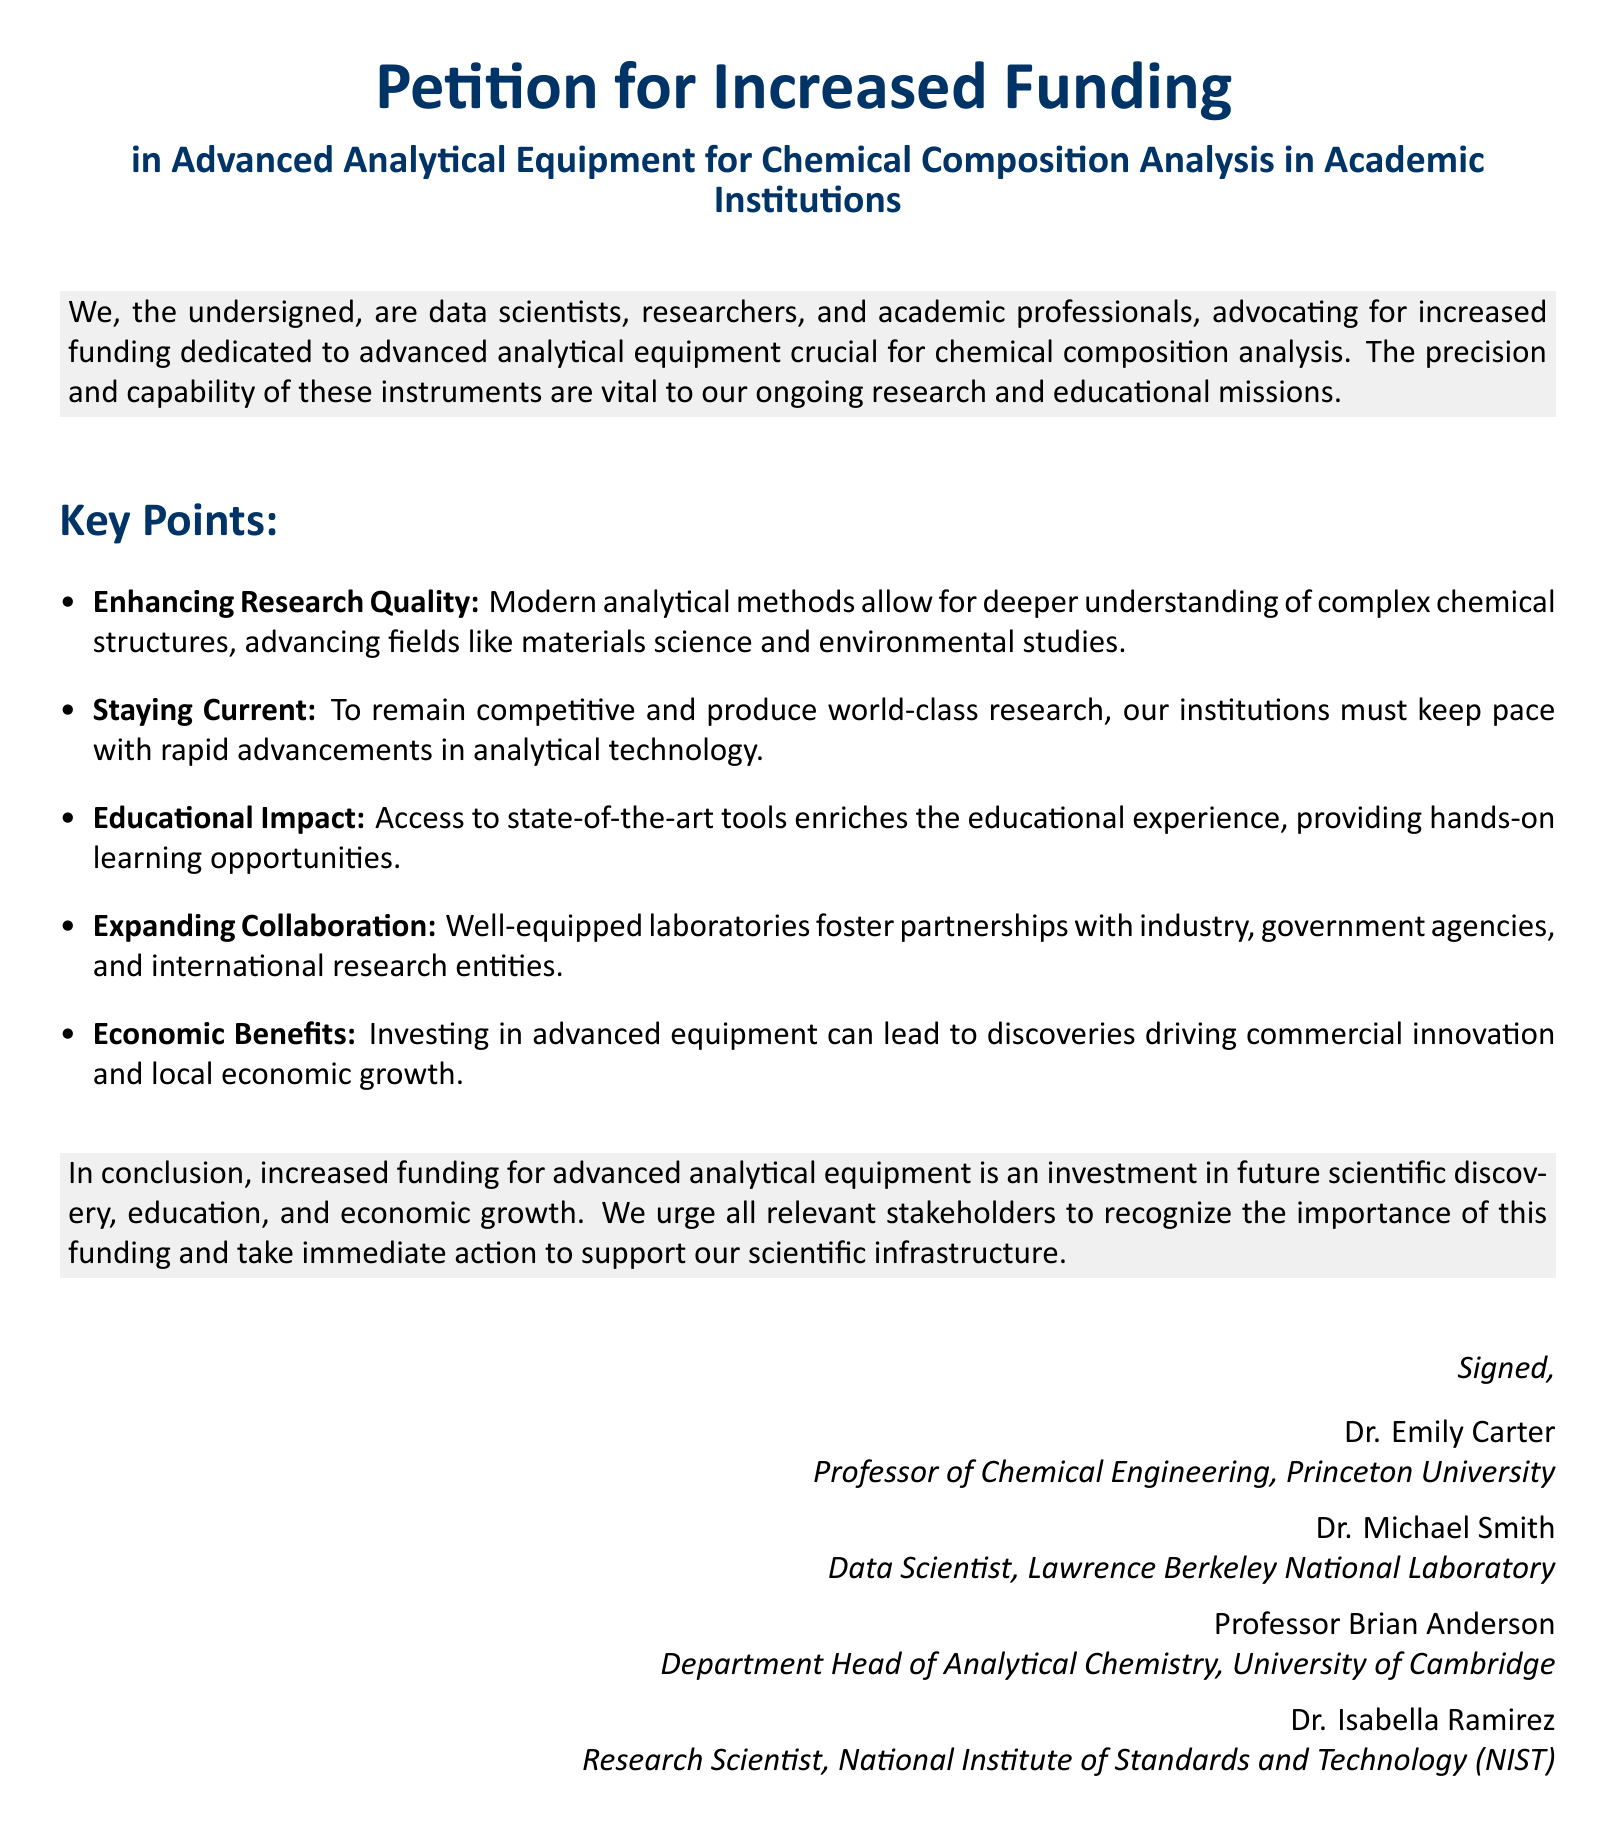What is the title of the petition? The title of the petition is indicated in the first section of the document.
Answer: Petition for Increased Funding in Advanced Analytical Equipment for Chemical Composition Analysis in Academic Institutions Who are the signatories listed in the document? The signatories' names and titles are provided in the conclusion section of the document.
Answer: Dr. Emily Carter, Dr. Michael Smith, Professor Brian Anderson, Dr. Isabella Ramirez What field of study does Dr. Emily Carter belong to? Dr. Emily Carter's field of study is mentioned in her title in the document.
Answer: Chemical Engineering What is one key point regarding the educational impact of funding? The document explicitly states the importance of access to tools for hands-on learning.
Answer: Providing hands-on learning opportunities How many key points are listed in the document? The total number of key points mentioned in the section is counted from the list provided.
Answer: Five What institution is Dr. Michael Smith associated with? The document provides the name of the institution in brackets next to Dr. Michael Smith's title.
Answer: Lawrence Berkeley National Laboratory What benefit other than educational impact is highlighted in the petition? The document features benefits from the economic point of view among other points.
Answer: Economic Benefits What color is used for the title of the petition? The document specifies a color for the title in the formatting section.
Answer: Petition blue 